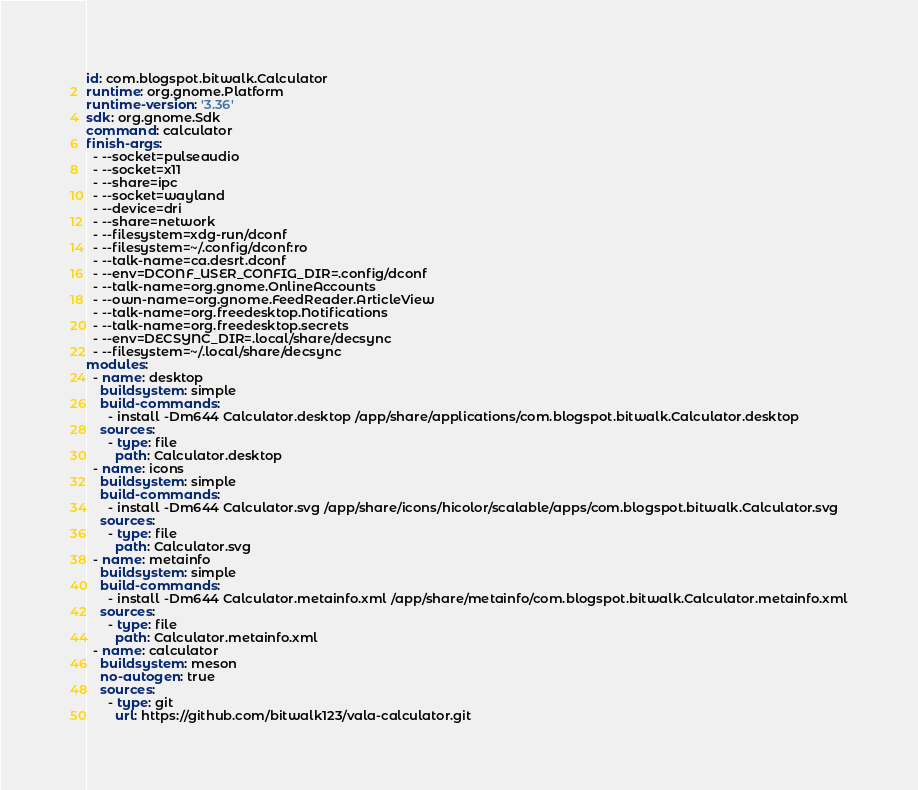<code> <loc_0><loc_0><loc_500><loc_500><_YAML_>id: com.blogspot.bitwalk.Calculator
runtime: org.gnome.Platform
runtime-version: '3.36'
sdk: org.gnome.Sdk
command: calculator
finish-args:
  - --socket=pulseaudio
  - --socket=x11 
  - --share=ipc
  - --socket=wayland
  - --device=dri
  - --share=network
  - --filesystem=xdg-run/dconf
  - --filesystem=~/.config/dconf:ro
  - --talk-name=ca.desrt.dconf
  - --env=DCONF_USER_CONFIG_DIR=.config/dconf
  - --talk-name=org.gnome.OnlineAccounts
  - --own-name=org.gnome.FeedReader.ArticleView
  - --talk-name=org.freedesktop.Notifications
  - --talk-name=org.freedesktop.secrets
  - --env=DECSYNC_DIR=.local/share/decsync
  - --filesystem=~/.local/share/decsync
modules:
  - name: desktop
    buildsystem: simple
    build-commands:
      - install -Dm644 Calculator.desktop /app/share/applications/com.blogspot.bitwalk.Calculator.desktop
    sources:
      - type: file
        path: Calculator.desktop
  - name: icons
    buildsystem: simple
    build-commands:
      - install -Dm644 Calculator.svg /app/share/icons/hicolor/scalable/apps/com.blogspot.bitwalk.Calculator.svg
    sources:
      - type: file
        path: Calculator.svg
  - name: metainfo
    buildsystem: simple
    build-commands:
      - install -Dm644 Calculator.metainfo.xml /app/share/metainfo/com.blogspot.bitwalk.Calculator.metainfo.xml
    sources:
      - type: file
        path: Calculator.metainfo.xml
  - name: calculator
    buildsystem: meson
    no-autogen: true
    sources:
      - type: git
        url: https://github.com/bitwalk123/vala-calculator.git

</code> 